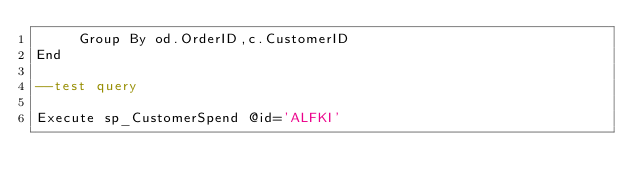Convert code to text. <code><loc_0><loc_0><loc_500><loc_500><_SQL_>	 Group By od.OrderID,c.CustomerID
End

--test query

Execute sp_CustomerSpend @id='ALFKI'</code> 